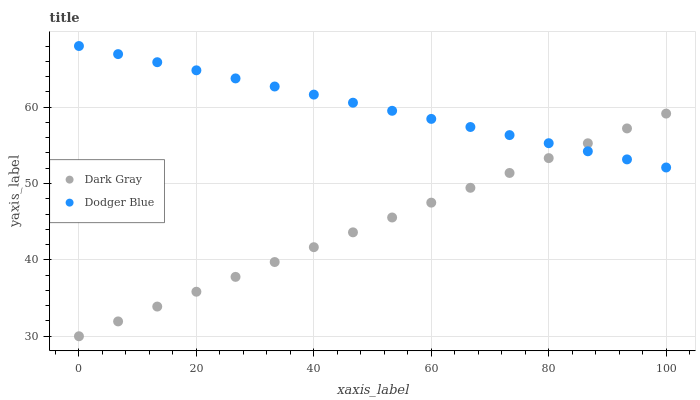Does Dark Gray have the minimum area under the curve?
Answer yes or no. Yes. Does Dodger Blue have the maximum area under the curve?
Answer yes or no. Yes. Does Dodger Blue have the minimum area under the curve?
Answer yes or no. No. Is Dark Gray the smoothest?
Answer yes or no. Yes. Is Dodger Blue the roughest?
Answer yes or no. Yes. Is Dodger Blue the smoothest?
Answer yes or no. No. Does Dark Gray have the lowest value?
Answer yes or no. Yes. Does Dodger Blue have the lowest value?
Answer yes or no. No. Does Dodger Blue have the highest value?
Answer yes or no. Yes. Does Dodger Blue intersect Dark Gray?
Answer yes or no. Yes. Is Dodger Blue less than Dark Gray?
Answer yes or no. No. Is Dodger Blue greater than Dark Gray?
Answer yes or no. No. 